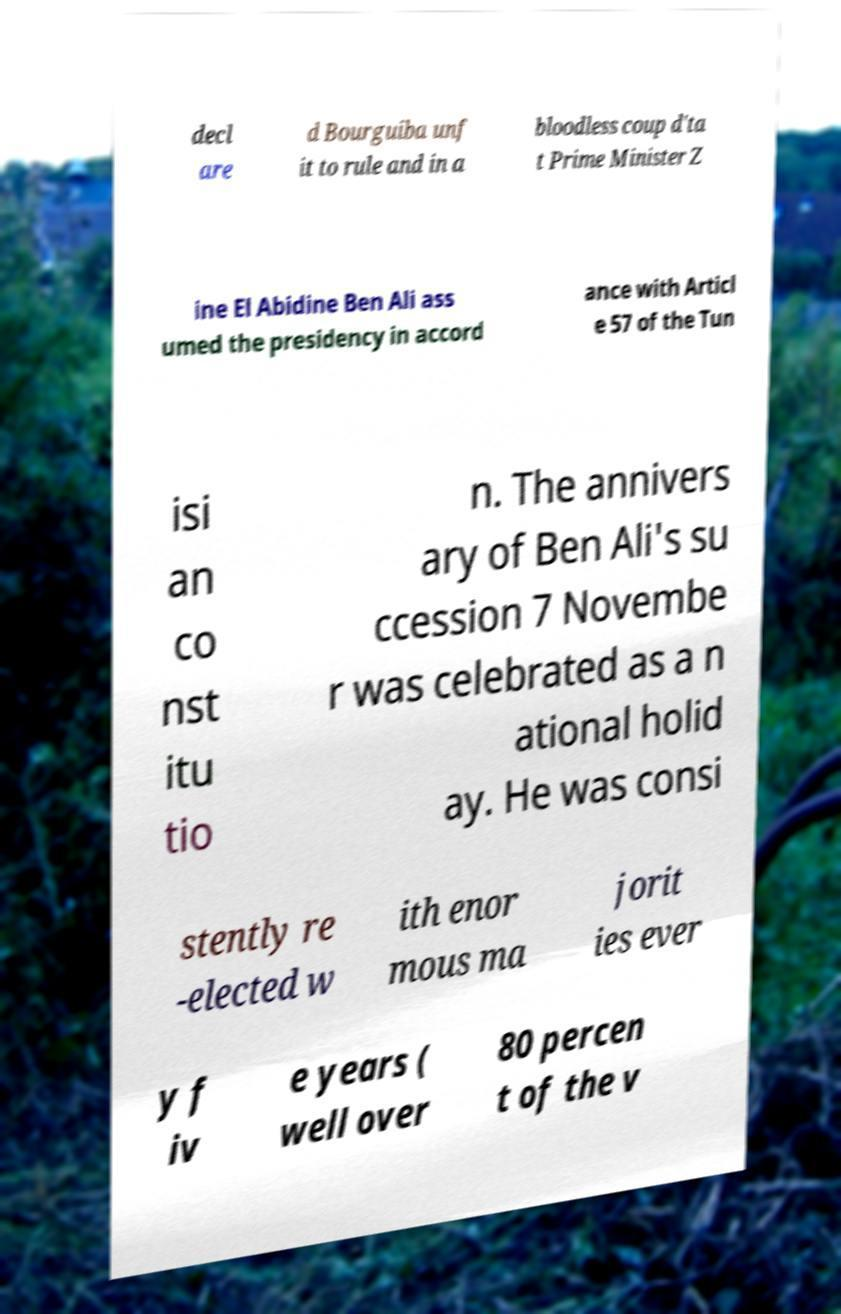For documentation purposes, I need the text within this image transcribed. Could you provide that? decl are d Bourguiba unf it to rule and in a bloodless coup d'ta t Prime Minister Z ine El Abidine Ben Ali ass umed the presidency in accord ance with Articl e 57 of the Tun isi an co nst itu tio n. The annivers ary of Ben Ali's su ccession 7 Novembe r was celebrated as a n ational holid ay. He was consi stently re -elected w ith enor mous ma jorit ies ever y f iv e years ( well over 80 percen t of the v 